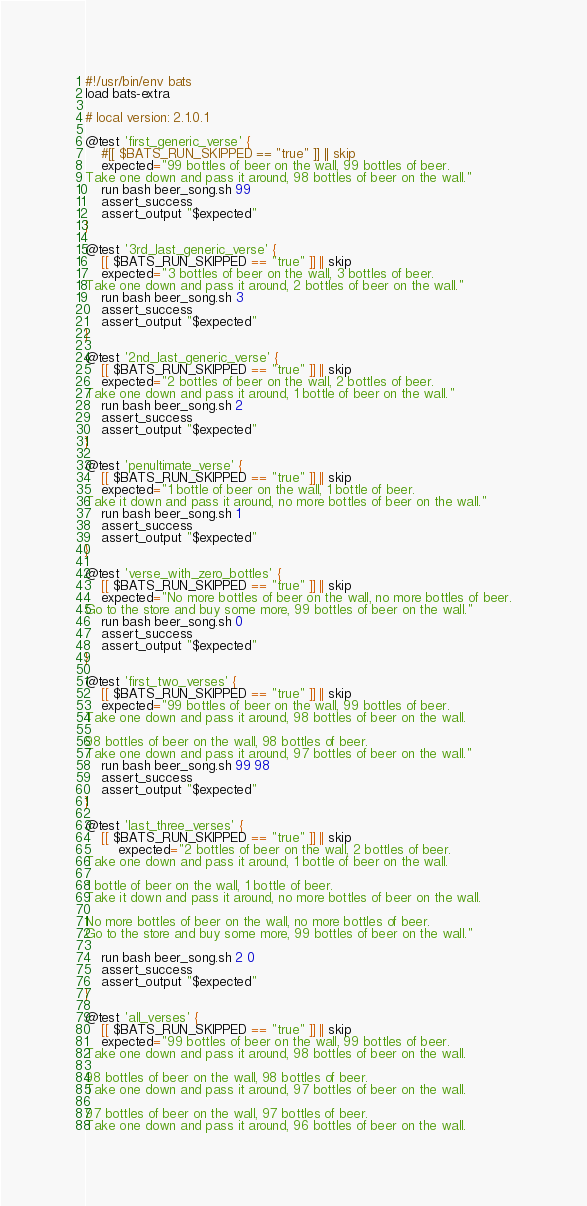Convert code to text. <code><loc_0><loc_0><loc_500><loc_500><_Bash_>#!/usr/bin/env bats
load bats-extra

# local version: 2.1.0.1

@test 'first_generic_verse' {
    #[[ $BATS_RUN_SKIPPED == "true" ]] || skip
    expected="99 bottles of beer on the wall, 99 bottles of beer.
Take one down and pass it around, 98 bottles of beer on the wall."
    run bash beer_song.sh 99
    assert_success
    assert_output "$expected"
}

@test '3rd_last_generic_verse' {
    [[ $BATS_RUN_SKIPPED == "true" ]] || skip
    expected="3 bottles of beer on the wall, 3 bottles of beer.
Take one down and pass it around, 2 bottles of beer on the wall."
    run bash beer_song.sh 3
    assert_success
    assert_output "$expected"
}

@test '2nd_last_generic_verse' {
    [[ $BATS_RUN_SKIPPED == "true" ]] || skip
    expected="2 bottles of beer on the wall, 2 bottles of beer.
Take one down and pass it around, 1 bottle of beer on the wall."
    run bash beer_song.sh 2
    assert_success
    assert_output "$expected"
}

@test 'penultimate_verse' {
    [[ $BATS_RUN_SKIPPED == "true" ]] || skip
    expected="1 bottle of beer on the wall, 1 bottle of beer.
Take it down and pass it around, no more bottles of beer on the wall."
    run bash beer_song.sh 1
    assert_success
    assert_output "$expected"
}

@test 'verse_with_zero_bottles' {
    [[ $BATS_RUN_SKIPPED == "true" ]] || skip
    expected="No more bottles of beer on the wall, no more bottles of beer.
Go to the store and buy some more, 99 bottles of beer on the wall."
    run bash beer_song.sh 0
    assert_success
    assert_output "$expected"
}

@test 'first_two_verses' {
    [[ $BATS_RUN_SKIPPED == "true" ]] || skip
    expected="99 bottles of beer on the wall, 99 bottles of beer.
Take one down and pass it around, 98 bottles of beer on the wall.

98 bottles of beer on the wall, 98 bottles of beer.
Take one down and pass it around, 97 bottles of beer on the wall."
    run bash beer_song.sh 99 98
    assert_success
    assert_output "$expected"
}

@test 'last_three_verses' {
    [[ $BATS_RUN_SKIPPED == "true" ]] || skip
        expected="2 bottles of beer on the wall, 2 bottles of beer.
Take one down and pass it around, 1 bottle of beer on the wall.

1 bottle of beer on the wall, 1 bottle of beer.
Take it down and pass it around, no more bottles of beer on the wall.

No more bottles of beer on the wall, no more bottles of beer.
Go to the store and buy some more, 99 bottles of beer on the wall."

    run bash beer_song.sh 2 0
    assert_success
    assert_output "$expected"
}

@test 'all_verses' {
    [[ $BATS_RUN_SKIPPED == "true" ]] || skip
    expected="99 bottles of beer on the wall, 99 bottles of beer.
Take one down and pass it around, 98 bottles of beer on the wall.

98 bottles of beer on the wall, 98 bottles of beer.
Take one down and pass it around, 97 bottles of beer on the wall.

97 bottles of beer on the wall, 97 bottles of beer.
Take one down and pass it around, 96 bottles of beer on the wall.
</code> 